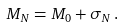Convert formula to latex. <formula><loc_0><loc_0><loc_500><loc_500>M _ { N } = M _ { 0 } + \sigma _ { N } \, .</formula> 